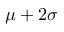Convert formula to latex. <formula><loc_0><loc_0><loc_500><loc_500>\mu + 2 \sigma</formula> 